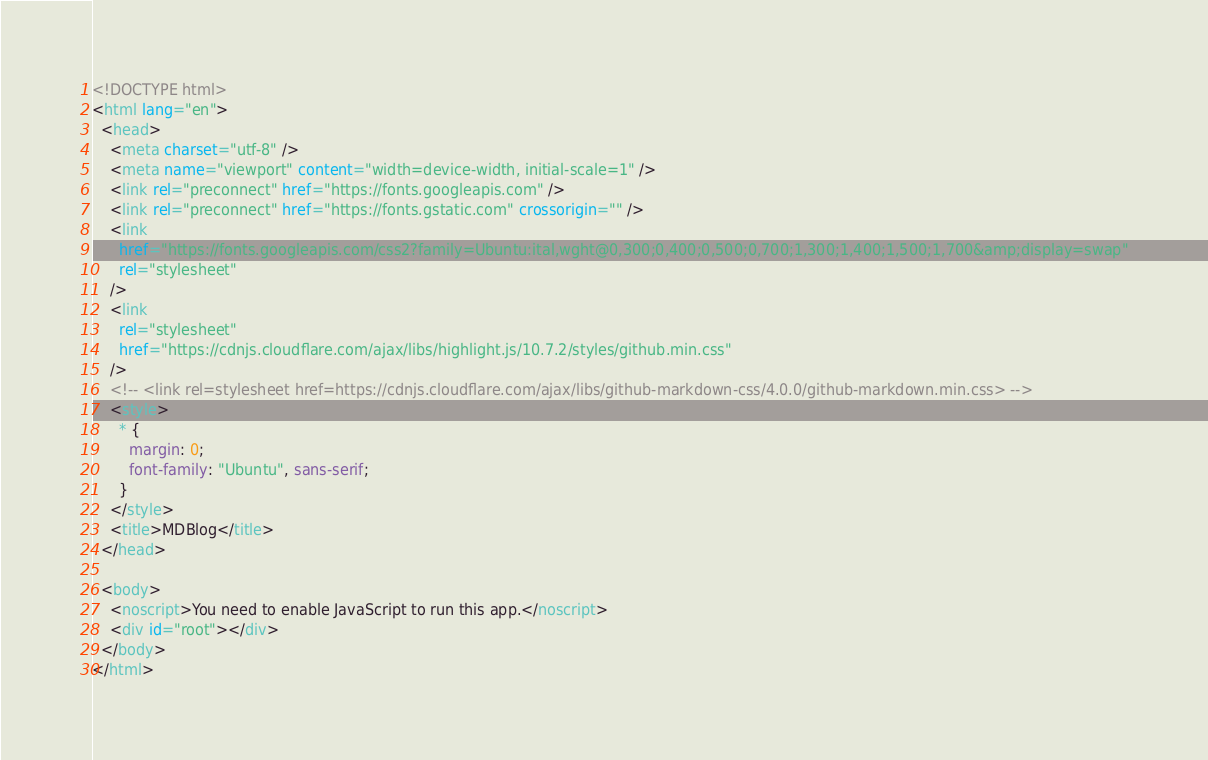<code> <loc_0><loc_0><loc_500><loc_500><_HTML_><!DOCTYPE html>
<html lang="en">
  <head>
    <meta charset="utf-8" />
    <meta name="viewport" content="width=device-width, initial-scale=1" />
    <link rel="preconnect" href="https://fonts.googleapis.com" />
    <link rel="preconnect" href="https://fonts.gstatic.com" crossorigin="" />
    <link
      href="https://fonts.googleapis.com/css2?family=Ubuntu:ital,wght@0,300;0,400;0,500;0,700;1,300;1,400;1,500;1,700&amp;display=swap"
      rel="stylesheet"
    />
    <link
      rel="stylesheet"
      href="https://cdnjs.cloudflare.com/ajax/libs/highlight.js/10.7.2/styles/github.min.css"
    />
    <!-- <link rel=stylesheet href=https://cdnjs.cloudflare.com/ajax/libs/github-markdown-css/4.0.0/github-markdown.min.css> -->
    <style>
      * {
        margin: 0;
        font-family: "Ubuntu", sans-serif;
      }
    </style>
    <title>MDBlog</title>
  </head>

  <body>
    <noscript>You need to enable JavaScript to run this app.</noscript>
    <div id="root"></div>
  </body>
</html>
</code> 